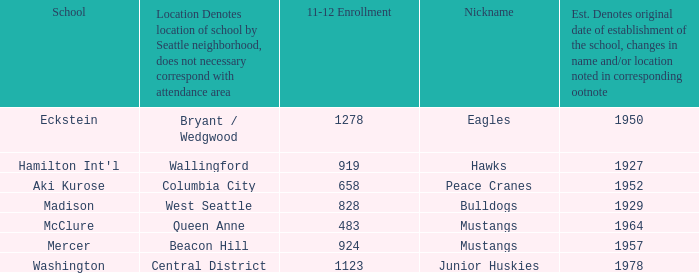Name the most 11-12 enrollment for columbia city 658.0. Parse the table in full. {'header': ['School', 'Location Denotes location of school by Seattle neighborhood, does not necessary correspond with attendance area', '11-12 Enrollment', 'Nickname', 'Est. Denotes original date of establishment of the school, changes in name and/or location noted in corresponding ootnote'], 'rows': [['Eckstein', 'Bryant / Wedgwood', '1278', 'Eagles', '1950'], ["Hamilton Int'l", 'Wallingford', '919', 'Hawks', '1927'], ['Aki Kurose', 'Columbia City', '658', 'Peace Cranes', '1952'], ['Madison', 'West Seattle', '828', 'Bulldogs', '1929'], ['McClure', 'Queen Anne', '483', 'Mustangs', '1964'], ['Mercer', 'Beacon Hill', '924', 'Mustangs', '1957'], ['Washington', 'Central District', '1123', 'Junior Huskies', '1978']]} 